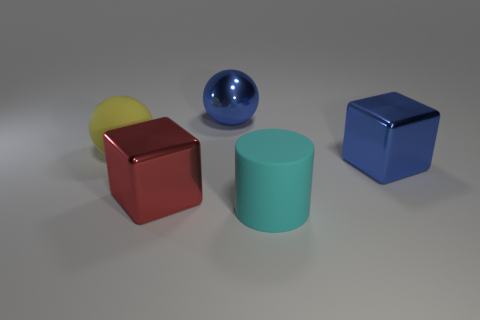Subtract all blue blocks. How many blocks are left? 1 Add 5 blue things. How many objects exist? 10 Subtract 1 balls. How many balls are left? 1 Add 2 small green rubber spheres. How many small green rubber spheres exist? 2 Subtract 0 gray cylinders. How many objects are left? 5 Subtract all blocks. How many objects are left? 3 Subtract all gray cubes. Subtract all gray spheres. How many cubes are left? 2 Subtract all brown balls. How many blue blocks are left? 1 Subtract all small gray shiny spheres. Subtract all metal cubes. How many objects are left? 3 Add 5 cyan matte objects. How many cyan matte objects are left? 6 